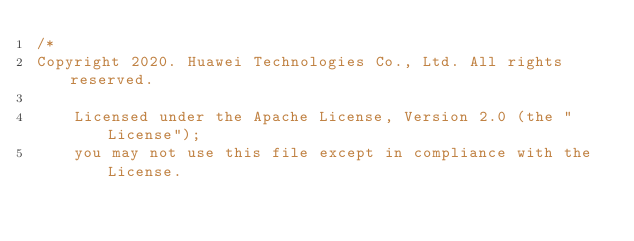Convert code to text. <code><loc_0><loc_0><loc_500><loc_500><_Java_>/*
Copyright 2020. Huawei Technologies Co., Ltd. All rights reserved.

    Licensed under the Apache License, Version 2.0 (the "License");
    you may not use this file except in compliance with the License.</code> 